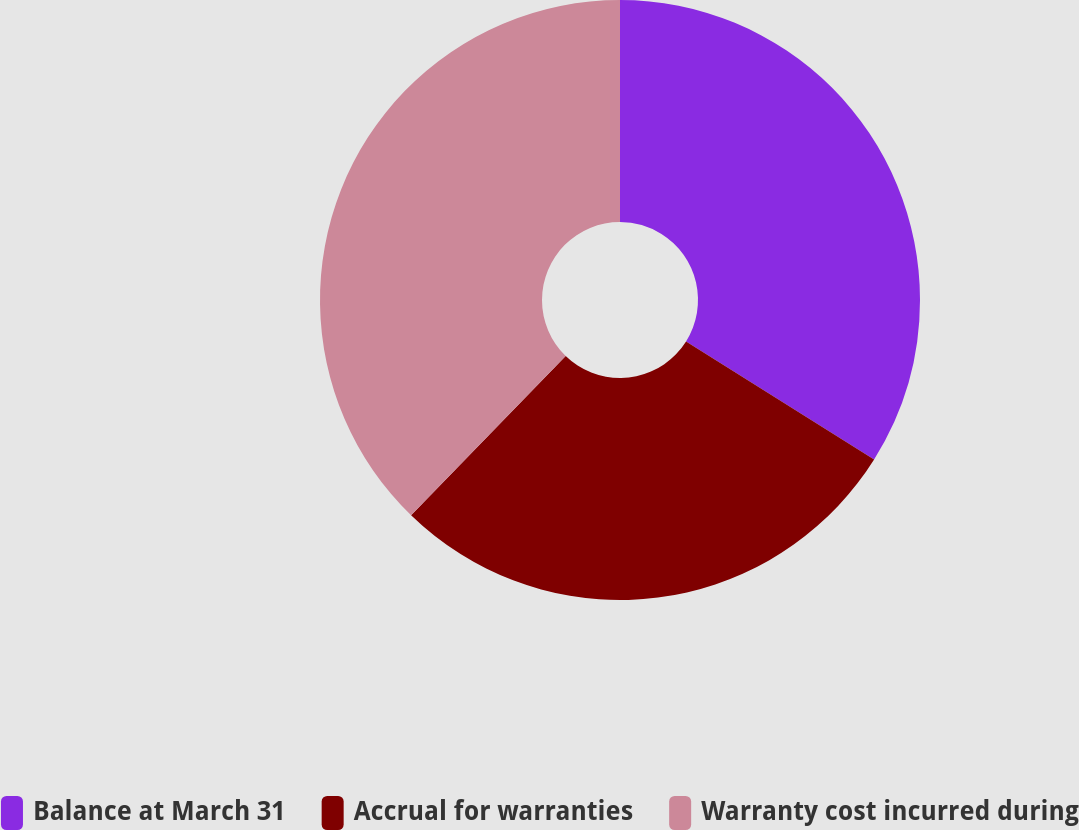<chart> <loc_0><loc_0><loc_500><loc_500><pie_chart><fcel>Balance at March 31<fcel>Accrual for warranties<fcel>Warranty cost incurred during<nl><fcel>33.92%<fcel>28.34%<fcel>37.74%<nl></chart> 